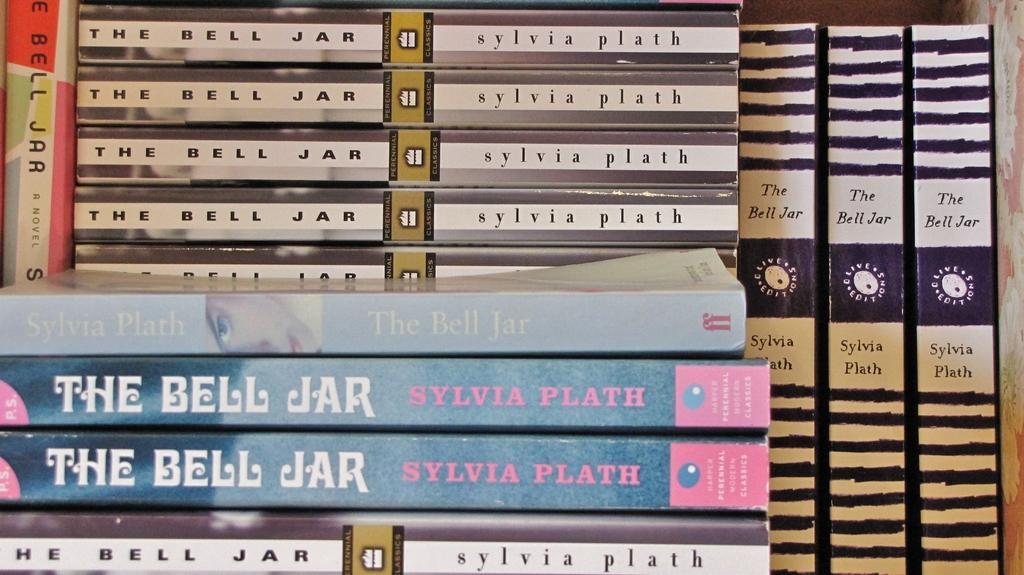<image>
Render a clear and concise summary of the photo. Several copies of the book "The Bell Jar" stacked next to each other. 